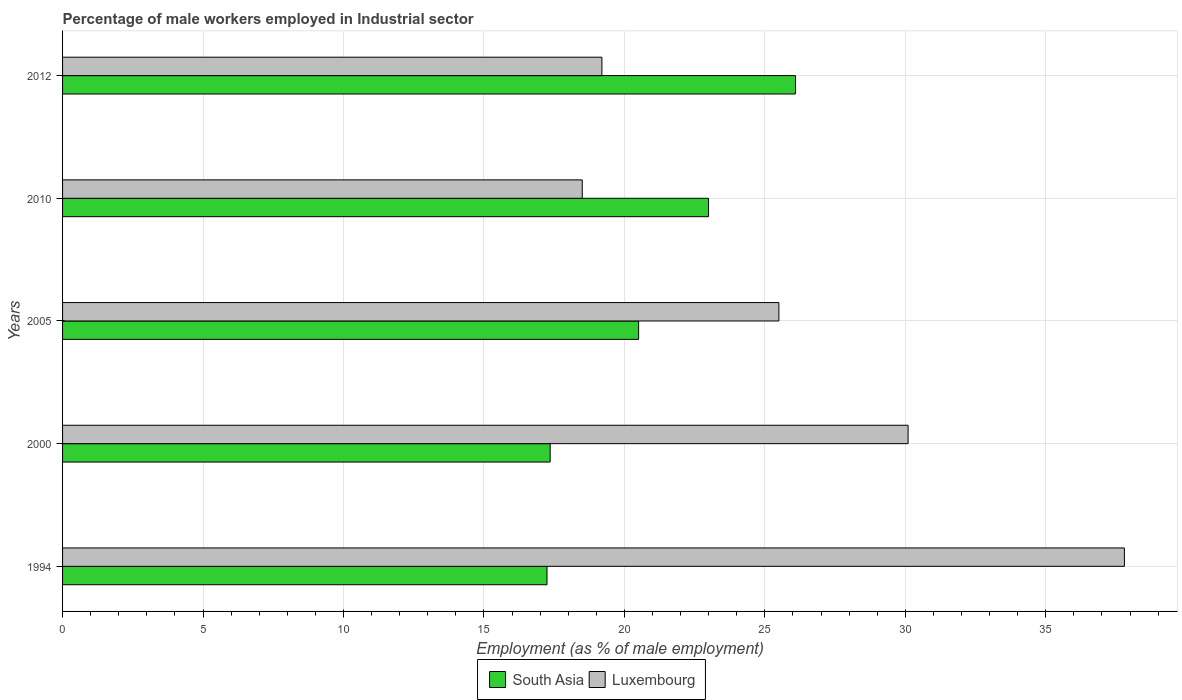How many bars are there on the 3rd tick from the top?
Your answer should be very brief. 2. What is the label of the 3rd group of bars from the top?
Ensure brevity in your answer.  2005. In how many cases, is the number of bars for a given year not equal to the number of legend labels?
Offer a terse response. 0. What is the percentage of male workers employed in Industrial sector in South Asia in 2012?
Offer a very short reply. 26.09. Across all years, what is the maximum percentage of male workers employed in Industrial sector in Luxembourg?
Offer a very short reply. 37.8. Across all years, what is the minimum percentage of male workers employed in Industrial sector in South Asia?
Your answer should be very brief. 17.25. In which year was the percentage of male workers employed in Industrial sector in South Asia maximum?
Ensure brevity in your answer.  2012. What is the total percentage of male workers employed in Industrial sector in South Asia in the graph?
Provide a short and direct response. 104.2. What is the difference between the percentage of male workers employed in Industrial sector in Luxembourg in 2010 and that in 2012?
Offer a terse response. -0.7. What is the difference between the percentage of male workers employed in Industrial sector in Luxembourg in 2010 and the percentage of male workers employed in Industrial sector in South Asia in 1994?
Make the answer very short. 1.25. What is the average percentage of male workers employed in Industrial sector in Luxembourg per year?
Provide a short and direct response. 26.22. In the year 1994, what is the difference between the percentage of male workers employed in Industrial sector in South Asia and percentage of male workers employed in Industrial sector in Luxembourg?
Provide a succinct answer. -20.55. What is the ratio of the percentage of male workers employed in Industrial sector in Luxembourg in 1994 to that in 2000?
Offer a terse response. 1.26. Is the difference between the percentage of male workers employed in Industrial sector in South Asia in 2005 and 2012 greater than the difference between the percentage of male workers employed in Industrial sector in Luxembourg in 2005 and 2012?
Your answer should be compact. No. What is the difference between the highest and the second highest percentage of male workers employed in Industrial sector in South Asia?
Your answer should be compact. 3.1. What is the difference between the highest and the lowest percentage of male workers employed in Industrial sector in South Asia?
Offer a terse response. 8.85. In how many years, is the percentage of male workers employed in Industrial sector in South Asia greater than the average percentage of male workers employed in Industrial sector in South Asia taken over all years?
Keep it short and to the point. 2. What does the 2nd bar from the top in 2005 represents?
Your response must be concise. South Asia. What does the 2nd bar from the bottom in 2012 represents?
Keep it short and to the point. Luxembourg. Are the values on the major ticks of X-axis written in scientific E-notation?
Ensure brevity in your answer.  No. Does the graph contain any zero values?
Your response must be concise. No. Does the graph contain grids?
Provide a short and direct response. Yes. Where does the legend appear in the graph?
Keep it short and to the point. Bottom center. How many legend labels are there?
Provide a short and direct response. 2. How are the legend labels stacked?
Give a very brief answer. Horizontal. What is the title of the graph?
Provide a succinct answer. Percentage of male workers employed in Industrial sector. What is the label or title of the X-axis?
Ensure brevity in your answer.  Employment (as % of male employment). What is the Employment (as % of male employment) of South Asia in 1994?
Your answer should be very brief. 17.25. What is the Employment (as % of male employment) in Luxembourg in 1994?
Provide a succinct answer. 37.8. What is the Employment (as % of male employment) of South Asia in 2000?
Keep it short and to the point. 17.36. What is the Employment (as % of male employment) in Luxembourg in 2000?
Provide a short and direct response. 30.1. What is the Employment (as % of male employment) in South Asia in 2005?
Your answer should be compact. 20.51. What is the Employment (as % of male employment) in Luxembourg in 2005?
Offer a very short reply. 25.5. What is the Employment (as % of male employment) in South Asia in 2010?
Provide a short and direct response. 23. What is the Employment (as % of male employment) in South Asia in 2012?
Offer a very short reply. 26.09. What is the Employment (as % of male employment) in Luxembourg in 2012?
Your response must be concise. 19.2. Across all years, what is the maximum Employment (as % of male employment) of South Asia?
Provide a short and direct response. 26.09. Across all years, what is the maximum Employment (as % of male employment) in Luxembourg?
Give a very brief answer. 37.8. Across all years, what is the minimum Employment (as % of male employment) in South Asia?
Offer a very short reply. 17.25. Across all years, what is the minimum Employment (as % of male employment) of Luxembourg?
Give a very brief answer. 18.5. What is the total Employment (as % of male employment) in South Asia in the graph?
Offer a very short reply. 104.2. What is the total Employment (as % of male employment) in Luxembourg in the graph?
Keep it short and to the point. 131.1. What is the difference between the Employment (as % of male employment) of South Asia in 1994 and that in 2000?
Give a very brief answer. -0.11. What is the difference between the Employment (as % of male employment) of South Asia in 1994 and that in 2005?
Give a very brief answer. -3.26. What is the difference between the Employment (as % of male employment) of Luxembourg in 1994 and that in 2005?
Make the answer very short. 12.3. What is the difference between the Employment (as % of male employment) in South Asia in 1994 and that in 2010?
Ensure brevity in your answer.  -5.75. What is the difference between the Employment (as % of male employment) of Luxembourg in 1994 and that in 2010?
Provide a short and direct response. 19.3. What is the difference between the Employment (as % of male employment) of South Asia in 1994 and that in 2012?
Offer a very short reply. -8.85. What is the difference between the Employment (as % of male employment) of Luxembourg in 1994 and that in 2012?
Offer a terse response. 18.6. What is the difference between the Employment (as % of male employment) in South Asia in 2000 and that in 2005?
Provide a short and direct response. -3.15. What is the difference between the Employment (as % of male employment) of Luxembourg in 2000 and that in 2005?
Your answer should be very brief. 4.6. What is the difference between the Employment (as % of male employment) in South Asia in 2000 and that in 2010?
Keep it short and to the point. -5.64. What is the difference between the Employment (as % of male employment) in Luxembourg in 2000 and that in 2010?
Provide a short and direct response. 11.6. What is the difference between the Employment (as % of male employment) in South Asia in 2000 and that in 2012?
Ensure brevity in your answer.  -8.73. What is the difference between the Employment (as % of male employment) of South Asia in 2005 and that in 2010?
Offer a terse response. -2.49. What is the difference between the Employment (as % of male employment) of South Asia in 2005 and that in 2012?
Give a very brief answer. -5.59. What is the difference between the Employment (as % of male employment) of South Asia in 2010 and that in 2012?
Provide a short and direct response. -3.1. What is the difference between the Employment (as % of male employment) of Luxembourg in 2010 and that in 2012?
Ensure brevity in your answer.  -0.7. What is the difference between the Employment (as % of male employment) of South Asia in 1994 and the Employment (as % of male employment) of Luxembourg in 2000?
Offer a very short reply. -12.85. What is the difference between the Employment (as % of male employment) in South Asia in 1994 and the Employment (as % of male employment) in Luxembourg in 2005?
Offer a very short reply. -8.25. What is the difference between the Employment (as % of male employment) in South Asia in 1994 and the Employment (as % of male employment) in Luxembourg in 2010?
Offer a terse response. -1.25. What is the difference between the Employment (as % of male employment) in South Asia in 1994 and the Employment (as % of male employment) in Luxembourg in 2012?
Provide a succinct answer. -1.95. What is the difference between the Employment (as % of male employment) in South Asia in 2000 and the Employment (as % of male employment) in Luxembourg in 2005?
Give a very brief answer. -8.14. What is the difference between the Employment (as % of male employment) of South Asia in 2000 and the Employment (as % of male employment) of Luxembourg in 2010?
Give a very brief answer. -1.14. What is the difference between the Employment (as % of male employment) in South Asia in 2000 and the Employment (as % of male employment) in Luxembourg in 2012?
Your answer should be compact. -1.84. What is the difference between the Employment (as % of male employment) of South Asia in 2005 and the Employment (as % of male employment) of Luxembourg in 2010?
Give a very brief answer. 2.01. What is the difference between the Employment (as % of male employment) of South Asia in 2005 and the Employment (as % of male employment) of Luxembourg in 2012?
Provide a succinct answer. 1.31. What is the difference between the Employment (as % of male employment) in South Asia in 2010 and the Employment (as % of male employment) in Luxembourg in 2012?
Offer a terse response. 3.8. What is the average Employment (as % of male employment) in South Asia per year?
Your answer should be compact. 20.84. What is the average Employment (as % of male employment) of Luxembourg per year?
Offer a very short reply. 26.22. In the year 1994, what is the difference between the Employment (as % of male employment) in South Asia and Employment (as % of male employment) in Luxembourg?
Ensure brevity in your answer.  -20.55. In the year 2000, what is the difference between the Employment (as % of male employment) of South Asia and Employment (as % of male employment) of Luxembourg?
Keep it short and to the point. -12.74. In the year 2005, what is the difference between the Employment (as % of male employment) in South Asia and Employment (as % of male employment) in Luxembourg?
Ensure brevity in your answer.  -4.99. In the year 2010, what is the difference between the Employment (as % of male employment) in South Asia and Employment (as % of male employment) in Luxembourg?
Keep it short and to the point. 4.5. In the year 2012, what is the difference between the Employment (as % of male employment) in South Asia and Employment (as % of male employment) in Luxembourg?
Offer a terse response. 6.89. What is the ratio of the Employment (as % of male employment) in South Asia in 1994 to that in 2000?
Your response must be concise. 0.99. What is the ratio of the Employment (as % of male employment) of Luxembourg in 1994 to that in 2000?
Provide a succinct answer. 1.26. What is the ratio of the Employment (as % of male employment) in South Asia in 1994 to that in 2005?
Your response must be concise. 0.84. What is the ratio of the Employment (as % of male employment) in Luxembourg in 1994 to that in 2005?
Give a very brief answer. 1.48. What is the ratio of the Employment (as % of male employment) in South Asia in 1994 to that in 2010?
Offer a very short reply. 0.75. What is the ratio of the Employment (as % of male employment) of Luxembourg in 1994 to that in 2010?
Offer a terse response. 2.04. What is the ratio of the Employment (as % of male employment) in South Asia in 1994 to that in 2012?
Ensure brevity in your answer.  0.66. What is the ratio of the Employment (as % of male employment) of Luxembourg in 1994 to that in 2012?
Give a very brief answer. 1.97. What is the ratio of the Employment (as % of male employment) in South Asia in 2000 to that in 2005?
Your answer should be very brief. 0.85. What is the ratio of the Employment (as % of male employment) in Luxembourg in 2000 to that in 2005?
Keep it short and to the point. 1.18. What is the ratio of the Employment (as % of male employment) in South Asia in 2000 to that in 2010?
Offer a very short reply. 0.75. What is the ratio of the Employment (as % of male employment) in Luxembourg in 2000 to that in 2010?
Your answer should be compact. 1.63. What is the ratio of the Employment (as % of male employment) in South Asia in 2000 to that in 2012?
Give a very brief answer. 0.67. What is the ratio of the Employment (as % of male employment) in Luxembourg in 2000 to that in 2012?
Your answer should be very brief. 1.57. What is the ratio of the Employment (as % of male employment) of South Asia in 2005 to that in 2010?
Offer a terse response. 0.89. What is the ratio of the Employment (as % of male employment) of Luxembourg in 2005 to that in 2010?
Your answer should be compact. 1.38. What is the ratio of the Employment (as % of male employment) in South Asia in 2005 to that in 2012?
Make the answer very short. 0.79. What is the ratio of the Employment (as % of male employment) of Luxembourg in 2005 to that in 2012?
Offer a terse response. 1.33. What is the ratio of the Employment (as % of male employment) of South Asia in 2010 to that in 2012?
Offer a very short reply. 0.88. What is the ratio of the Employment (as % of male employment) in Luxembourg in 2010 to that in 2012?
Ensure brevity in your answer.  0.96. What is the difference between the highest and the second highest Employment (as % of male employment) of South Asia?
Keep it short and to the point. 3.1. What is the difference between the highest and the second highest Employment (as % of male employment) in Luxembourg?
Your response must be concise. 7.7. What is the difference between the highest and the lowest Employment (as % of male employment) in South Asia?
Keep it short and to the point. 8.85. What is the difference between the highest and the lowest Employment (as % of male employment) of Luxembourg?
Keep it short and to the point. 19.3. 